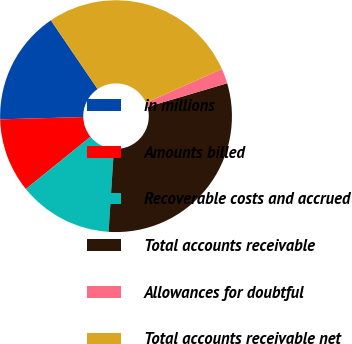Convert chart to OTSL. <chart><loc_0><loc_0><loc_500><loc_500><pie_chart><fcel>in millions<fcel>Amounts billed<fcel>Recoverable costs and accrued<fcel>Total accounts receivable<fcel>Allowances for doubtful<fcel>Total accounts receivable net<nl><fcel>15.94%<fcel>10.38%<fcel>13.16%<fcel>30.6%<fcel>2.1%<fcel>27.82%<nl></chart> 